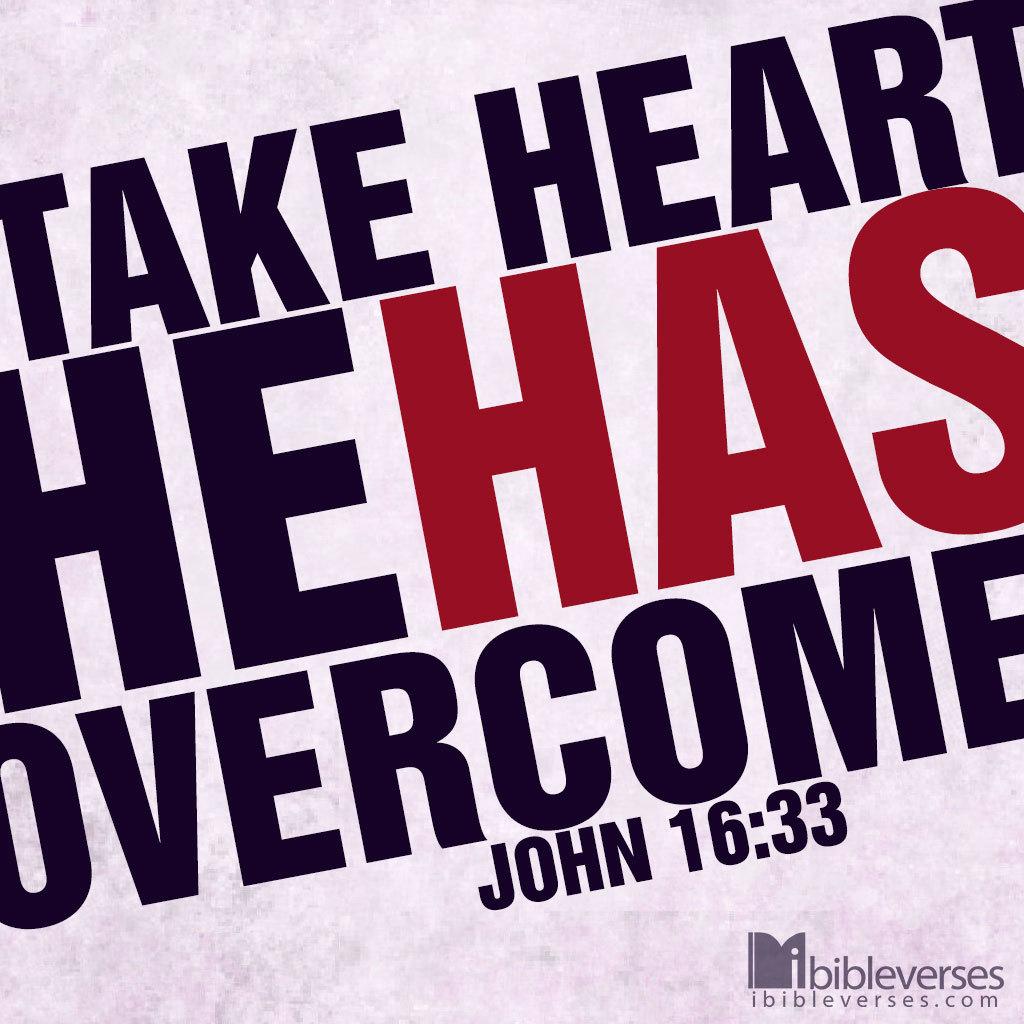What bible verse is this?
Provide a short and direct response. John 16:33. What is this quote?
Your answer should be compact. Take heart he has overcome. 